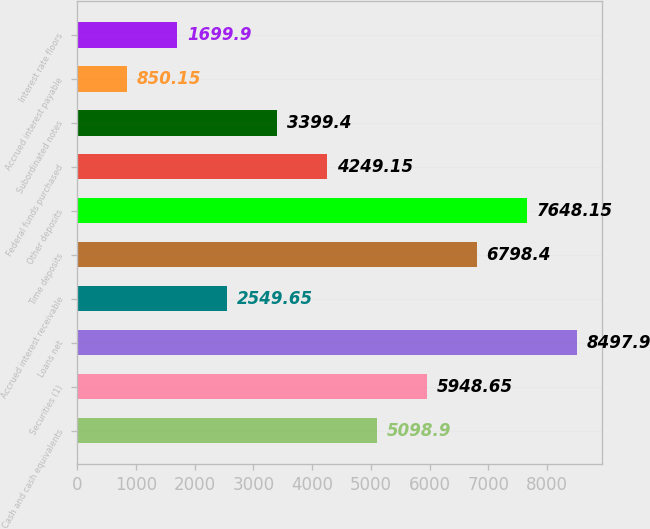Convert chart to OTSL. <chart><loc_0><loc_0><loc_500><loc_500><bar_chart><fcel>Cash and cash equivalents<fcel>Securities (1)<fcel>Loans net<fcel>Accrued interest receivable<fcel>Time deposits<fcel>Other deposits<fcel>Federal funds purchased<fcel>Subordinated notes<fcel>Accrued interest payable<fcel>Interest rate floors<nl><fcel>5098.9<fcel>5948.65<fcel>8497.9<fcel>2549.65<fcel>6798.4<fcel>7648.15<fcel>4249.15<fcel>3399.4<fcel>850.15<fcel>1699.9<nl></chart> 